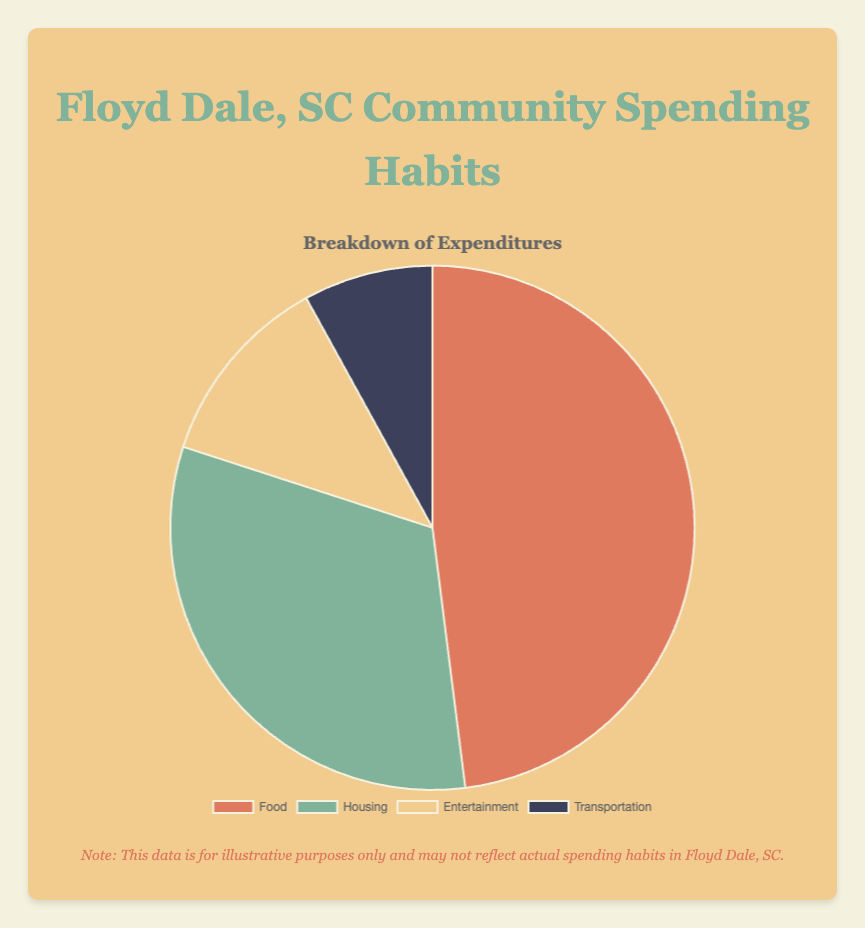Which category has the highest percentage of spending? By looking at the pie chart, we can see that the segment labeled "Food" is the largest.
Answer: Food What's the total percentage of spending for Food and Housing combined? The percentage for Food is 60% and for Housing is 40%. Adding these together, 60% + 40% = 100%.
Answer: 100% How much more percentage is spent on Food compared to Entertainment? The percentage for Food is 60% and for Entertainment is 15%. The difference is 60% - 15% = 45%.
Answer: 45% Is the spending on Food greater than the combined spending on Entertainment and Transportation? The spending on Food is 60%. Combined spending for Entertainment is 15% and for Transportation is 10%, which totals to 25%. Comparing, 60% > 25%.
Answer: Yes What is the smallest category of spending and its percentage? By examining the pie chart, we can see the smallest segment is "Transportation" which has a percentage of 10%.
Answer: Transportation, 10% If the community decides to cut Food spending by half and redistribute it evenly among Housing, Entertainment, and Transportation, what would be the new percentage of each of these three categories? If Food spending is cut by half, it drops to 30%. The remaining 30% is divided equally among Housing, Entertainment, and Transportation, giving each an additional 10%. Housing will be 40% + 10% = 50%, Entertainment will be 15% + 10% = 25%, and Transportation will be 10% + 10% = 20%.
Answer: Housing = 50%, Entertainment = 25%, Transportation = 20% How does spending on Housing compare to the sum of spending on Entertainment and Transportation? The spending on Housing is 40%. The combined spending on Entertainment and Transportation is 15% + 10% = 25%. Comparing, 40% > 25%.
Answer: Greater Which color represents Housing and what is the percentage spent on Housing? In the pie chart, Housing is represented by the green segment, which comprises 40% of the spending.
Answer: Green, 40% What is the total percentage spent on categories other than Food? The total percentage for categories other than Food is obtained by adding Housing (40%), Entertainment (15%), and Transportation (10%), which results in 40% + 15% + 10% = 65%.
Answer: 65% Which two categories combined form a larger segment than Food alone? The two categories are Housing (40%) and Entertainment (15%). Adding these together gives 40% + 15% = 55%, which is still less than Food's 60%. Thus, we include Transportation (10%) so the total becomes 40% + 15% + 10% = 65%, which is greater than Food's 60%.
Answer: Housing and Entertainment 